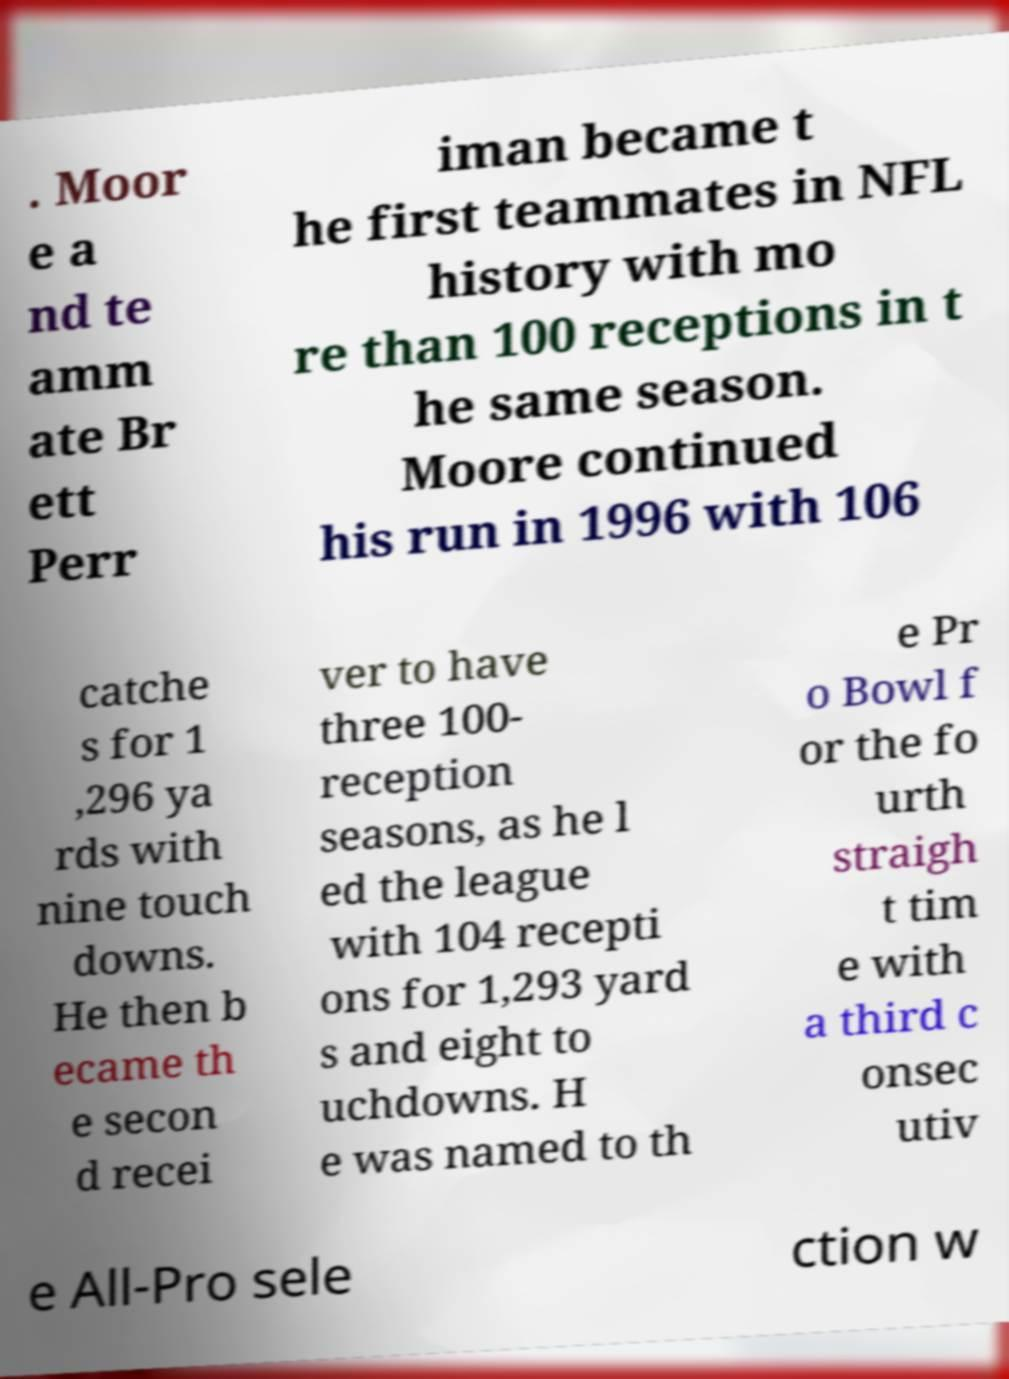I need the written content from this picture converted into text. Can you do that? . Moor e a nd te amm ate Br ett Perr iman became t he first teammates in NFL history with mo re than 100 receptions in t he same season. Moore continued his run in 1996 with 106 catche s for 1 ,296 ya rds with nine touch downs. He then b ecame th e secon d recei ver to have three 100- reception seasons, as he l ed the league with 104 recepti ons for 1,293 yard s and eight to uchdowns. H e was named to th e Pr o Bowl f or the fo urth straigh t tim e with a third c onsec utiv e All-Pro sele ction w 